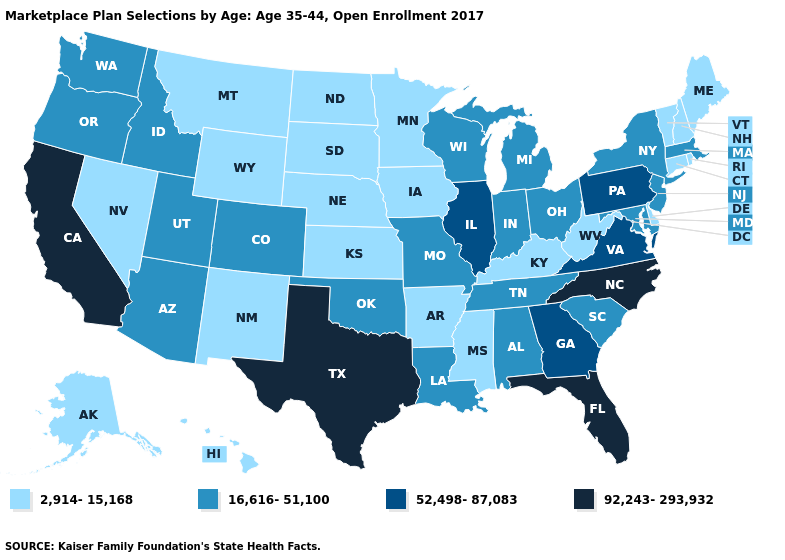What is the lowest value in states that border West Virginia?
Keep it brief. 2,914-15,168. Name the states that have a value in the range 92,243-293,932?
Be succinct. California, Florida, North Carolina, Texas. What is the highest value in the West ?
Write a very short answer. 92,243-293,932. Name the states that have a value in the range 92,243-293,932?
Short answer required. California, Florida, North Carolina, Texas. Among the states that border Texas , does Louisiana have the lowest value?
Quick response, please. No. What is the value of Minnesota?
Be succinct. 2,914-15,168. Is the legend a continuous bar?
Be succinct. No. Does Colorado have a higher value than Georgia?
Keep it brief. No. Which states have the lowest value in the USA?
Write a very short answer. Alaska, Arkansas, Connecticut, Delaware, Hawaii, Iowa, Kansas, Kentucky, Maine, Minnesota, Mississippi, Montana, Nebraska, Nevada, New Hampshire, New Mexico, North Dakota, Rhode Island, South Dakota, Vermont, West Virginia, Wyoming. How many symbols are there in the legend?
Keep it brief. 4. What is the value of Illinois?
Keep it brief. 52,498-87,083. What is the value of Iowa?
Write a very short answer. 2,914-15,168. Name the states that have a value in the range 2,914-15,168?
Answer briefly. Alaska, Arkansas, Connecticut, Delaware, Hawaii, Iowa, Kansas, Kentucky, Maine, Minnesota, Mississippi, Montana, Nebraska, Nevada, New Hampshire, New Mexico, North Dakota, Rhode Island, South Dakota, Vermont, West Virginia, Wyoming. What is the value of Minnesota?
Short answer required. 2,914-15,168. What is the value of Oklahoma?
Short answer required. 16,616-51,100. 